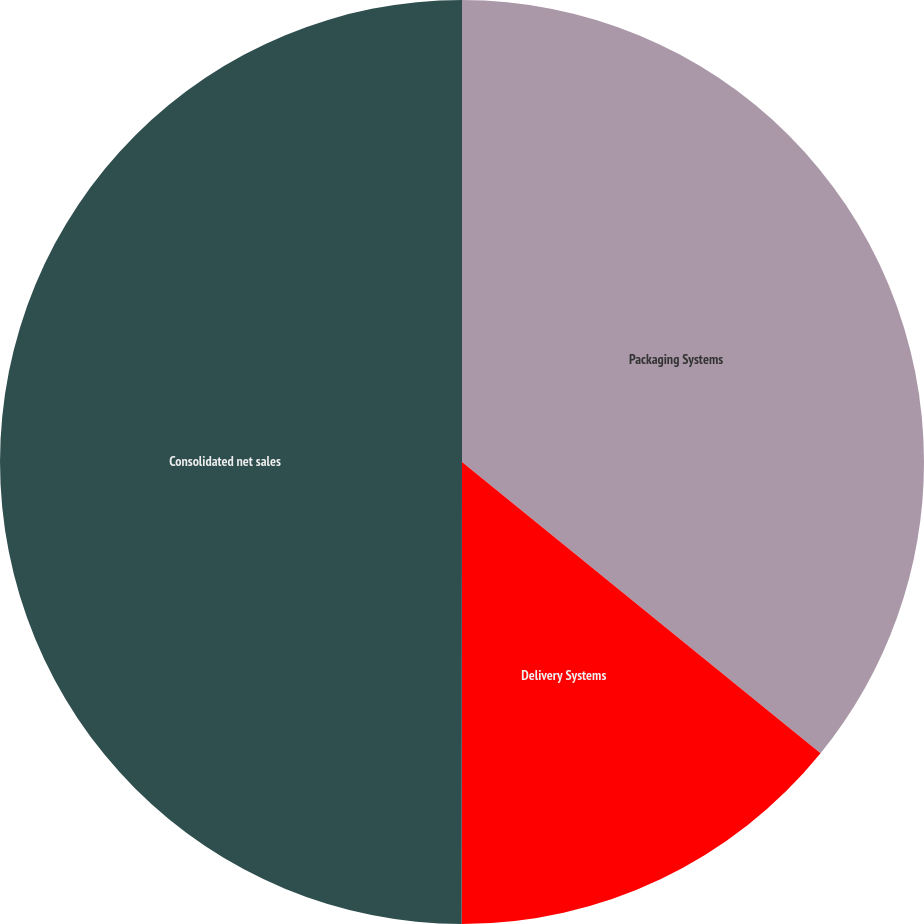Convert chart to OTSL. <chart><loc_0><loc_0><loc_500><loc_500><pie_chart><fcel>Packaging Systems<fcel>Delivery Systems<fcel>Consolidated net sales<nl><fcel>35.86%<fcel>14.15%<fcel>49.99%<nl></chart> 